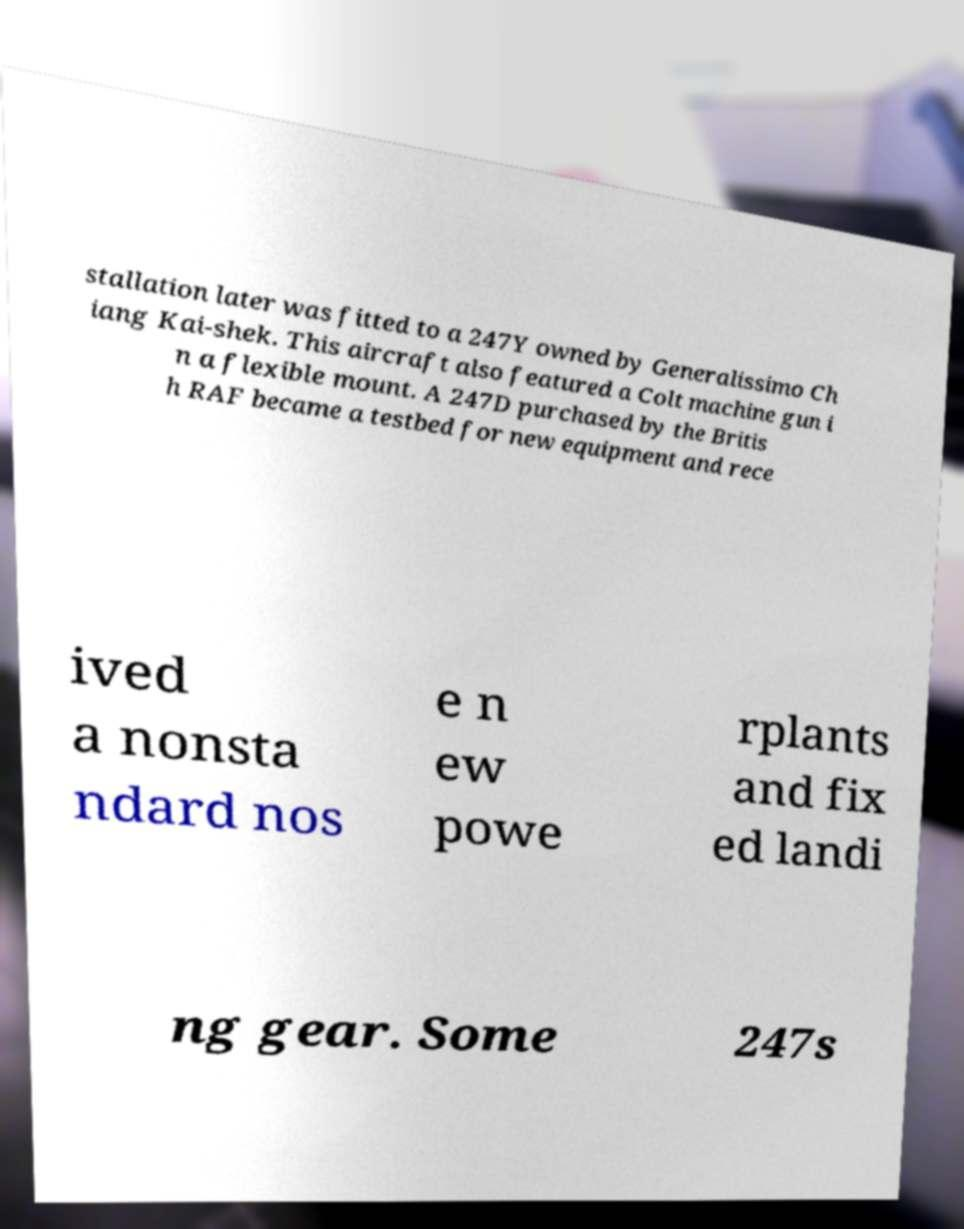Could you assist in decoding the text presented in this image and type it out clearly? stallation later was fitted to a 247Y owned by Generalissimo Ch iang Kai-shek. This aircraft also featured a Colt machine gun i n a flexible mount. A 247D purchased by the Britis h RAF became a testbed for new equipment and rece ived a nonsta ndard nos e n ew powe rplants and fix ed landi ng gear. Some 247s 